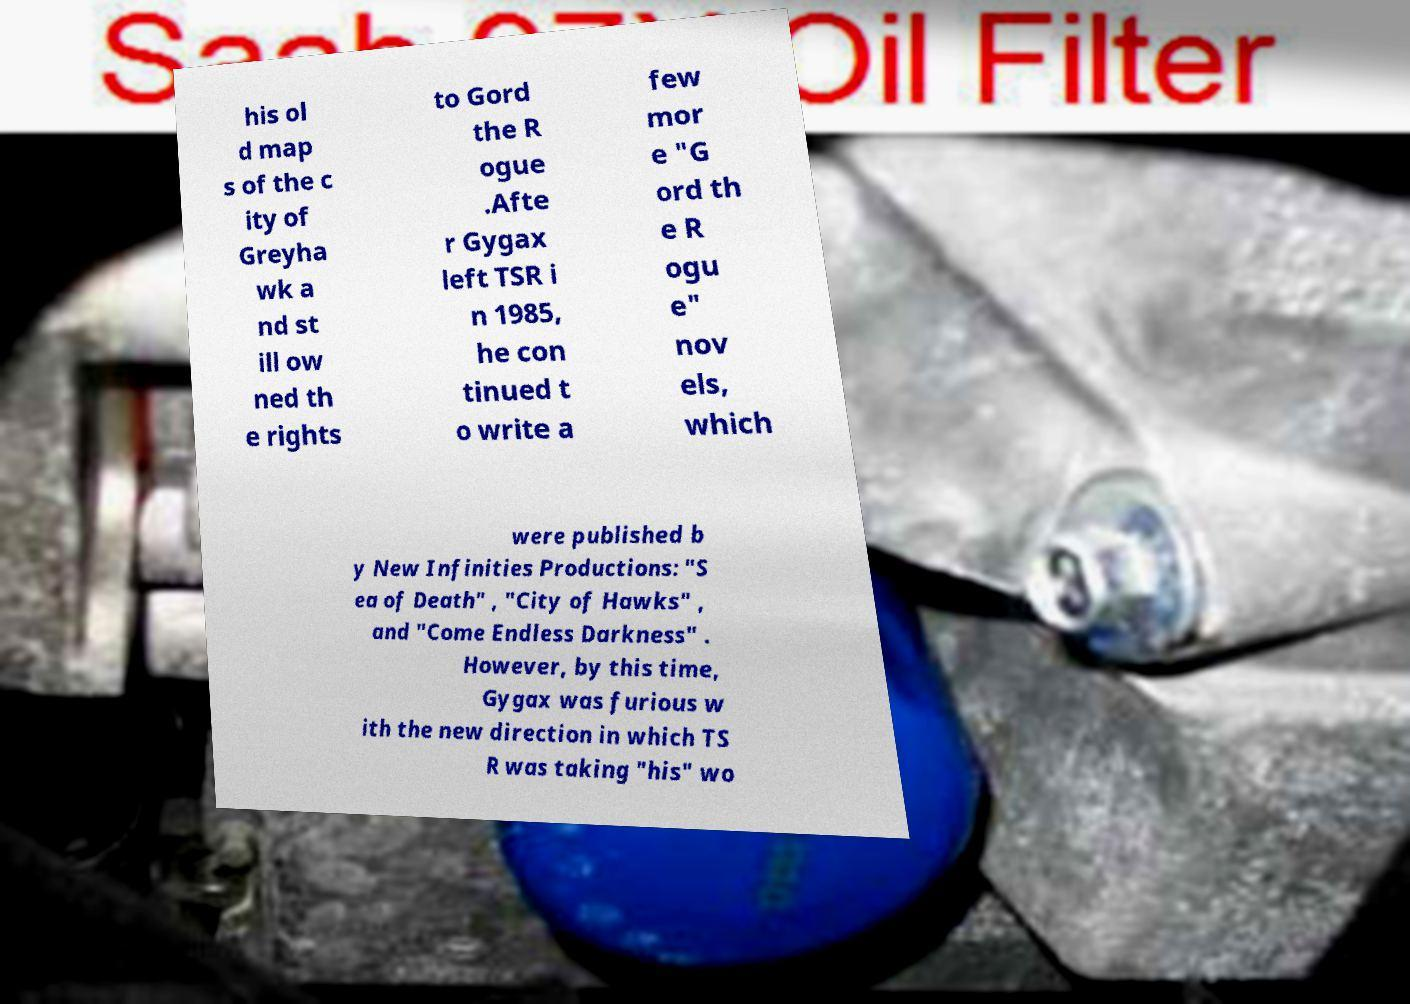Can you read and provide the text displayed in the image?This photo seems to have some interesting text. Can you extract and type it out for me? his ol d map s of the c ity of Greyha wk a nd st ill ow ned th e rights to Gord the R ogue .Afte r Gygax left TSR i n 1985, he con tinued t o write a few mor e "G ord th e R ogu e" nov els, which were published b y New Infinities Productions: "S ea of Death" , "City of Hawks" , and "Come Endless Darkness" . However, by this time, Gygax was furious w ith the new direction in which TS R was taking "his" wo 